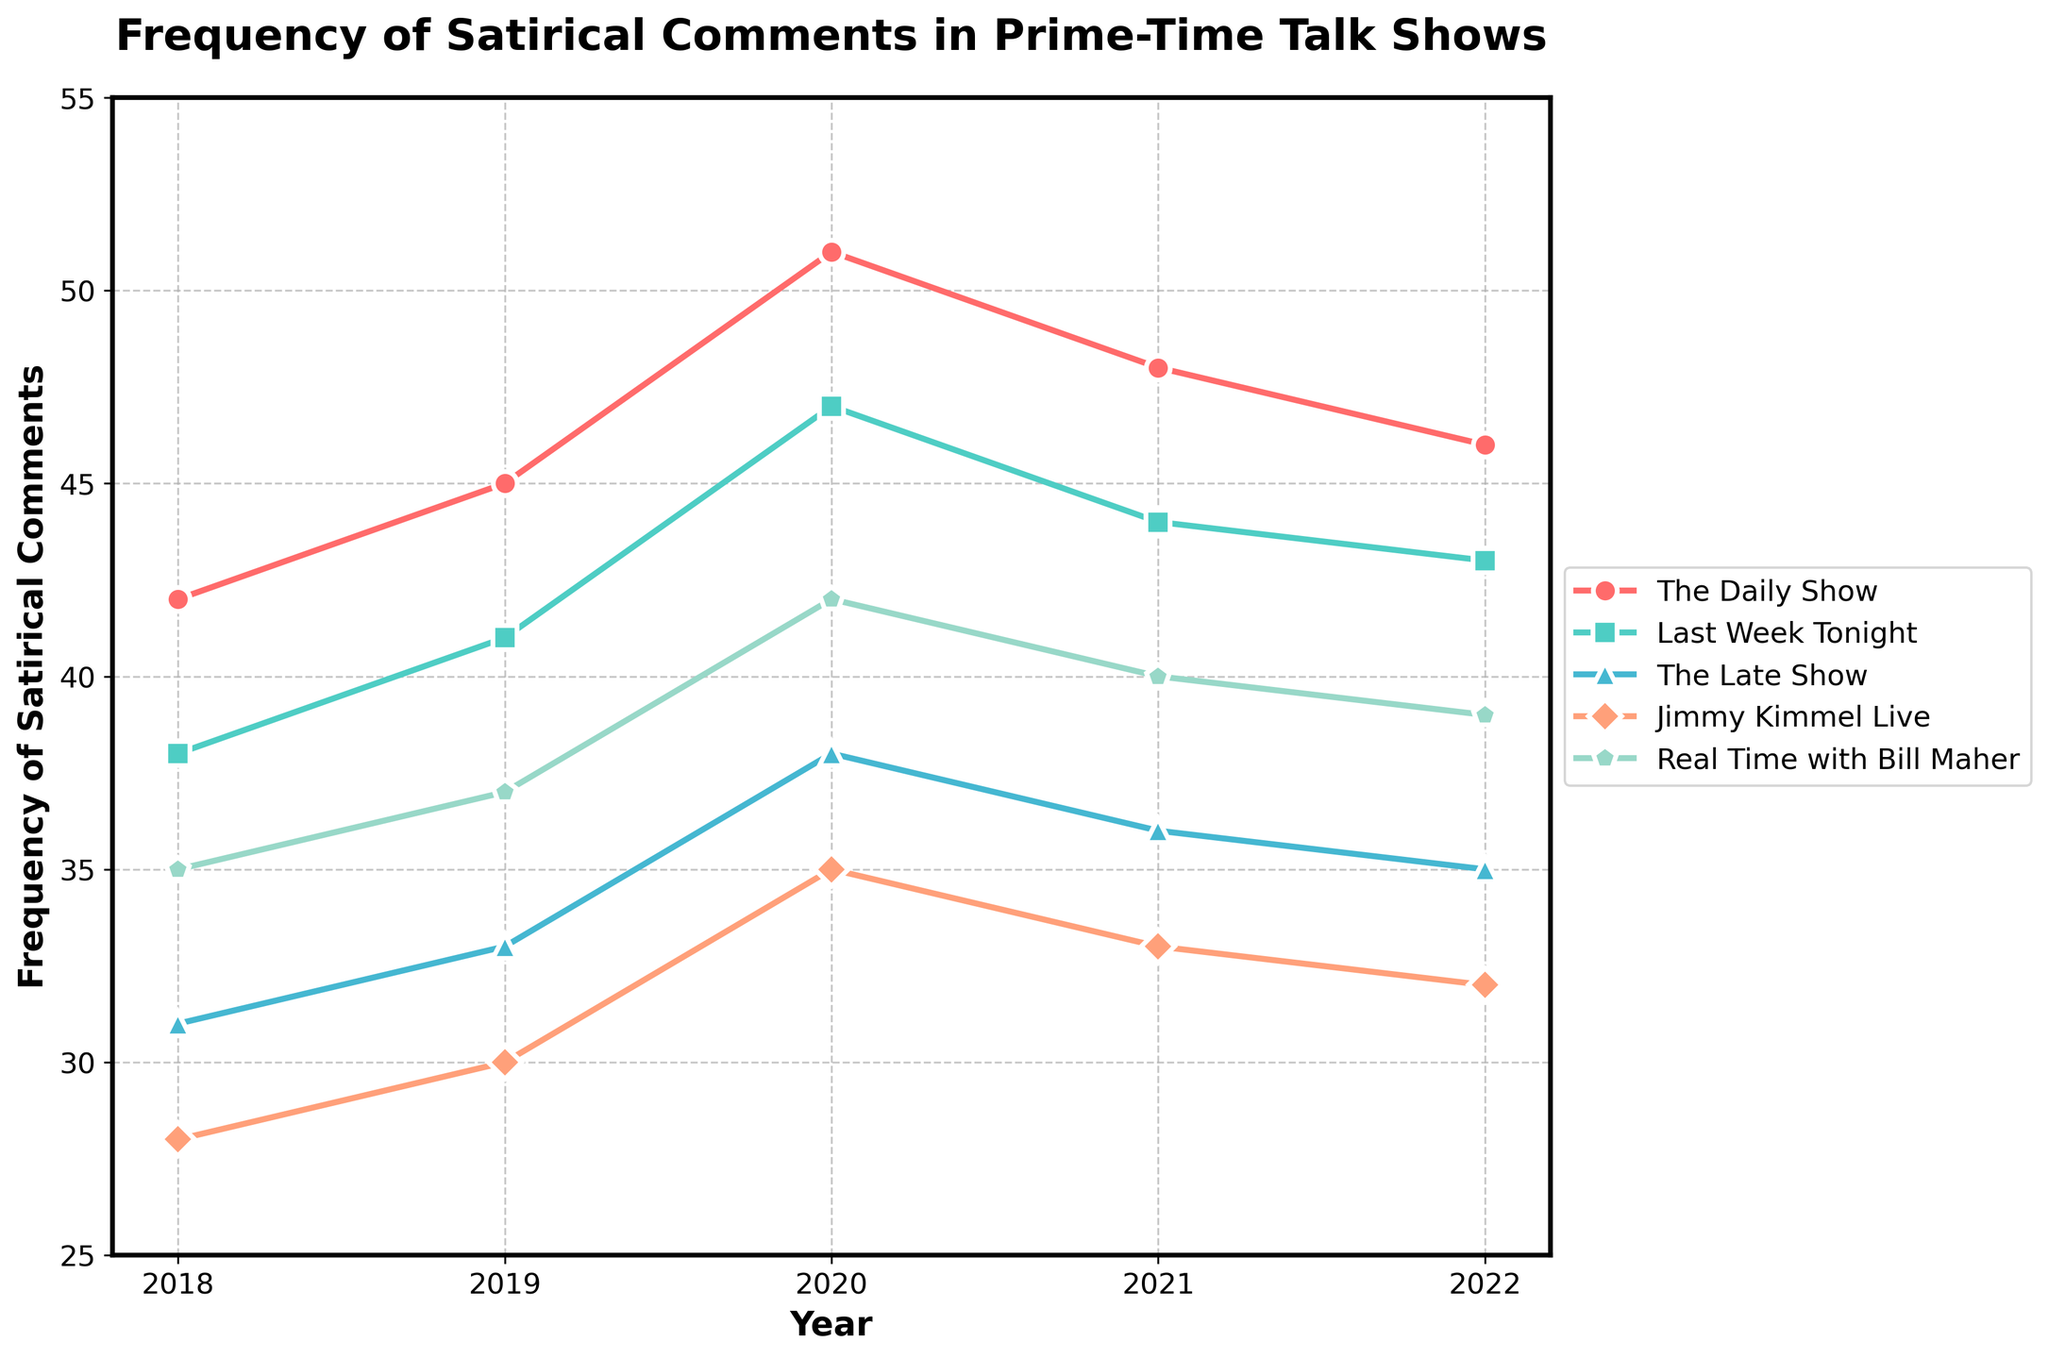What year did "The Daily Show" have the highest frequency of satirical comments? Looking at the plot, the highest point for "The Daily Show" is in the year 2020.
Answer: 2020 Which show had the lowest frequency of satirical comments in 2022? By comparing the endpoint of all lines for 2022, "Jimmy Kimmel Live" is the lowest.
Answer: Jimmy Kimmel Live How did the frequency of satirical comments on "The Late Show" change from 2018 to 2022? Read the point for "The Late Show" in 2018, which is 31, and compare it to the 2022 point, which is 35. The frequency increased by 4.
Answer: Increased by 4 Which show had the most consistent frequency of satirical comments over the five years? By examining the trends, "Real Time with Bill Maher" has the least variation, showing a smaller range from 35 to 42 over the years.
Answer: Real Time with Bill Maher In 2020, which show had the second highest frequency of satirical comments? In 2020, the second highest line is "Last Week Tonight" with 47, while the highest is "The Daily Show" at 51.
Answer: Last Week Tonight What's the average frequency of satirical comments for "Jimmy Kimmel Live" over 5 years? Sum the frequencies for "Jimmy Kimmel Live" and divide by 5: (28 + 30 + 35 + 33 + 32) / 5 = 31.6
Answer: 31.6 Which two shows had a crossover point in frequency between 2019 and 2020? "The Daily Show" and "Last Week Tonight" cross between 2019 and 2020, where "Last Week Tonight" overtakes "The Daily Show".
Answer: The Daily Show and Last Week Tonight In which year did "The Late Show" and "Real Time with Bill Maher" have the same frequency of satirical comments? By comparing the lines visually, in 2022 both "The Late Show" and "Real Time with Bill Maher" intersect at 35.
Answer: 2022 What is the difference in the frequency of satirical comments between "The Daily Show" and "Jimmy Kimmel Live" in 2022? "The Daily Show" has 46 and "Jimmy Kimmel Live" has 32 in 2022, the difference is 46 - 32 = 14.
Answer: 14 Which show has seen a consistent decline since 2020? "The Daily Show" has seen a consistent decline from 2020 onwards, from 51 to 46.
Answer: The Daily Show 